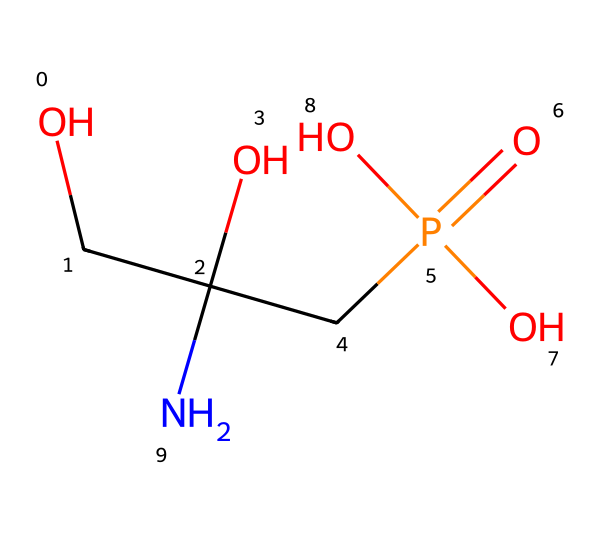What is the molecular formula of glyphosate? By analyzing the structure represented by the SMILES notation, we can identify the individual atoms present. Glyphosate consists of carbon (C), hydrogen (H), oxygen (O), phosphorus (P), and nitrogen (N). Counting the individual atoms gives us the molecular formula C3H8NO5P.
Answer: C3H8NO5P How many carbon atoms are in glyphosate? The SMILES notation indicates the presence of three carbon atoms within the structure. These are counted directly from the representation.
Answer: 3 Which functional groups are present in glyphosate? By analyzing the chemical structure, we can identify several functional groups: a phosphonic acid group (-P(=O)(O)O) and a hydroxyl group (-OH). This indicates the presence of both a phosphonic acid and alcohol groups.
Answer: phosphonic acid, hydroxyl What type of substance is glyphosate? Glyphosate is commonly categorized as an herbicide, a type of pesticide used to kill weeds. This categorization can be inferred from its common usage and the presence of functional groups that typically exhibit herbicidal properties.
Answer: herbicide How many nitrogen atoms are present in glyphosate? The analysis of the SMILES representation reveals there is one nitrogen atom in the structure. The presence of nitrogen can be directly observed as part of the overall framework.
Answer: 1 What is the primary use of glyphosate? Glyphosate is primarily used as a herbicide to control weeds. Its chemical properties make it effective in preventing or inhibiting weed growth, which can be inferred from its application in agricultural practices.
Answer: herbicide 